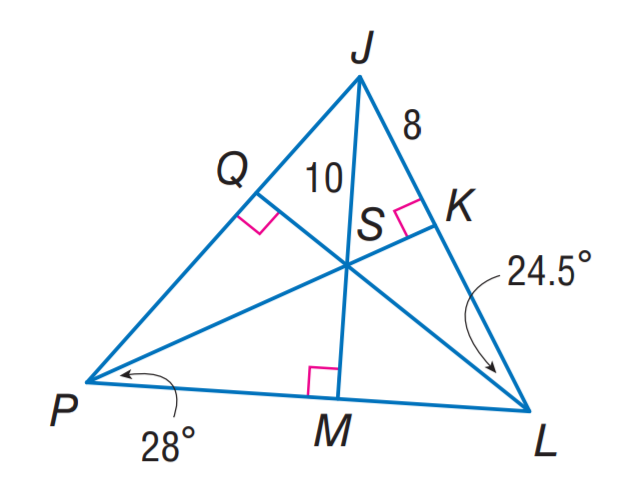Question: Point S is the incenter of \triangle J P L. Find m \angle S J P.
Choices:
A. 24.5
B. 37.5
C. 56
D. 75
Answer with the letter. Answer: B Question: Point S is the incenter of \triangle J P L. Find m \angle M P Q.
Choices:
A. 24.5
B. 28
C. 49
D. 56
Answer with the letter. Answer: D 